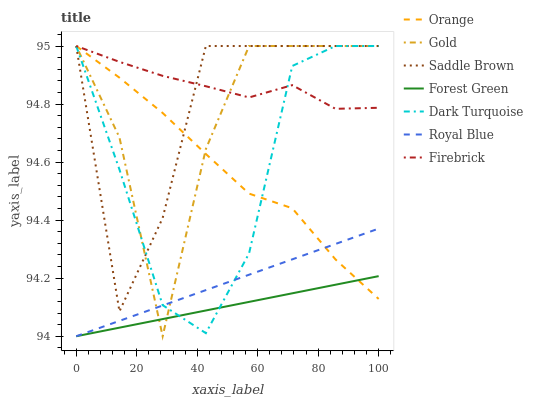Does Dark Turquoise have the minimum area under the curve?
Answer yes or no. No. Does Dark Turquoise have the maximum area under the curve?
Answer yes or no. No. Is Dark Turquoise the smoothest?
Answer yes or no. No. Is Dark Turquoise the roughest?
Answer yes or no. No. Does Dark Turquoise have the lowest value?
Answer yes or no. No. Does Royal Blue have the highest value?
Answer yes or no. No. Is Forest Green less than Saddle Brown?
Answer yes or no. Yes. Is Saddle Brown greater than Forest Green?
Answer yes or no. Yes. Does Forest Green intersect Saddle Brown?
Answer yes or no. No. 